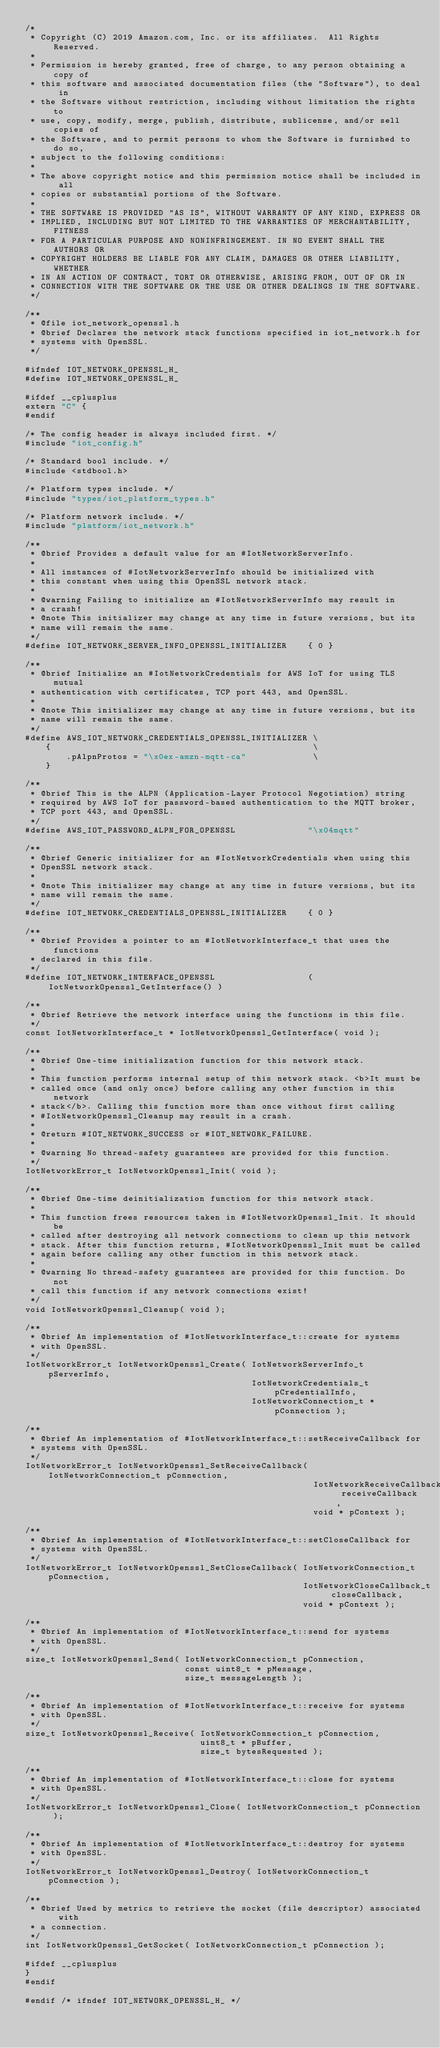<code> <loc_0><loc_0><loc_500><loc_500><_C_>/*
 * Copyright (C) 2019 Amazon.com, Inc. or its affiliates.  All Rights Reserved.
 *
 * Permission is hereby granted, free of charge, to any person obtaining a copy of
 * this software and associated documentation files (the "Software"), to deal in
 * the Software without restriction, including without limitation the rights to
 * use, copy, modify, merge, publish, distribute, sublicense, and/or sell copies of
 * the Software, and to permit persons to whom the Software is furnished to do so,
 * subject to the following conditions:
 *
 * The above copyright notice and this permission notice shall be included in all
 * copies or substantial portions of the Software.
 *
 * THE SOFTWARE IS PROVIDED "AS IS", WITHOUT WARRANTY OF ANY KIND, EXPRESS OR
 * IMPLIED, INCLUDING BUT NOT LIMITED TO THE WARRANTIES OF MERCHANTABILITY, FITNESS
 * FOR A PARTICULAR PURPOSE AND NONINFRINGEMENT. IN NO EVENT SHALL THE AUTHORS OR
 * COPYRIGHT HOLDERS BE LIABLE FOR ANY CLAIM, DAMAGES OR OTHER LIABILITY, WHETHER
 * IN AN ACTION OF CONTRACT, TORT OR OTHERWISE, ARISING FROM, OUT OF OR IN
 * CONNECTION WITH THE SOFTWARE OR THE USE OR OTHER DEALINGS IN THE SOFTWARE.
 */

/**
 * @file iot_network_openssl.h
 * @brief Declares the network stack functions specified in iot_network.h for
 * systems with OpenSSL.
 */

#ifndef IOT_NETWORK_OPENSSL_H_
#define IOT_NETWORK_OPENSSL_H_

#ifdef __cplusplus
extern "C" {
#endif

/* The config header is always included first. */
#include "iot_config.h"

/* Standard bool include. */
#include <stdbool.h>

/* Platform types include. */
#include "types/iot_platform_types.h"

/* Platform network include. */
#include "platform/iot_network.h"

/**
 * @brief Provides a default value for an #IotNetworkServerInfo.
 *
 * All instances of #IotNetworkServerInfo should be initialized with
 * this constant when using this OpenSSL network stack.
 *
 * @warning Failing to initialize an #IotNetworkServerInfo may result in
 * a crash!
 * @note This initializer may change at any time in future versions, but its
 * name will remain the same.
 */
#define IOT_NETWORK_SERVER_INFO_OPENSSL_INITIALIZER    { 0 }

/**
 * @brief Initialize an #IotNetworkCredentials for AWS IoT for using TLS mutual
 * authentication with certificates, TCP port 443, and OpenSSL.
 *
 * @note This initializer may change at any time in future versions, but its
 * name will remain the same.
 */
#define AWS_IOT_NETWORK_CREDENTIALS_OPENSSL_INITIALIZER \
    {                                                   \
        .pAlpnProtos = "\x0ex-amzn-mqtt-ca"             \
    }

/**
 * @brief This is the ALPN (Application-Layer Protocol Negotiation) string
 * required by AWS IoT for password-based authentication to the MQTT broker,
 * TCP port 443, and OpenSSL.
 */
#define AWS_IOT_PASSWORD_ALPN_FOR_OPENSSL              "\x04mqtt"

/**
 * @brief Generic initializer for an #IotNetworkCredentials when using this
 * OpenSSL network stack.
 *
 * @note This initializer may change at any time in future versions, but its
 * name will remain the same.
 */
#define IOT_NETWORK_CREDENTIALS_OPENSSL_INITIALIZER    { 0 }

/**
 * @brief Provides a pointer to an #IotNetworkInterface_t that uses the functions
 * declared in this file.
 */
#define IOT_NETWORK_INTERFACE_OPENSSL                  ( IotNetworkOpenssl_GetInterface() )

/**
 * @brief Retrieve the network interface using the functions in this file.
 */
const IotNetworkInterface_t * IotNetworkOpenssl_GetInterface( void );

/**
 * @brief One-time initialization function for this network stack.
 *
 * This function performs internal setup of this network stack. <b>It must be
 * called once (and only once) before calling any other function in this network
 * stack</b>. Calling this function more than once without first calling
 * #IotNetworkOpenssl_Cleanup may result in a crash.
 *
 * @return #IOT_NETWORK_SUCCESS or #IOT_NETWORK_FAILURE.
 *
 * @warning No thread-safety guarantees are provided for this function.
 */
IotNetworkError_t IotNetworkOpenssl_Init( void );

/**
 * @brief One-time deinitialization function for this network stack.
 *
 * This function frees resources taken in #IotNetworkOpenssl_Init. It should be
 * called after destroying all network connections to clean up this network
 * stack. After this function returns, #IotNetworkOpenssl_Init must be called
 * again before calling any other function in this network stack.
 *
 * @warning No thread-safety guarantees are provided for this function. Do not
 * call this function if any network connections exist!
 */
void IotNetworkOpenssl_Cleanup( void );

/**
 * @brief An implementation of #IotNetworkInterface_t::create for systems
 * with OpenSSL.
 */
IotNetworkError_t IotNetworkOpenssl_Create( IotNetworkServerInfo_t pServerInfo,
                                            IotNetworkCredentials_t pCredentialInfo,
                                            IotNetworkConnection_t * pConnection );

/**
 * @brief An implementation of #IotNetworkInterface_t::setReceiveCallback for
 * systems with OpenSSL.
 */
IotNetworkError_t IotNetworkOpenssl_SetReceiveCallback( IotNetworkConnection_t pConnection,
                                                        IotNetworkReceiveCallback_t receiveCallback,
                                                        void * pContext );

/**
 * @brief An implementation of #IotNetworkInterface_t::setCloseCallback for
 * systems with OpenSSL.
 */
IotNetworkError_t IotNetworkOpenssl_SetCloseCallback( IotNetworkConnection_t pConnection,
                                                      IotNetworkCloseCallback_t closeCallback,
                                                      void * pContext );

/**
 * @brief An implementation of #IotNetworkInterface_t::send for systems
 * with OpenSSL.
 */
size_t IotNetworkOpenssl_Send( IotNetworkConnection_t pConnection,
                               const uint8_t * pMessage,
                               size_t messageLength );

/**
 * @brief An implementation of #IotNetworkInterface_t::receive for systems
 * with OpenSSL.
 */
size_t IotNetworkOpenssl_Receive( IotNetworkConnection_t pConnection,
                                  uint8_t * pBuffer,
                                  size_t bytesRequested );

/**
 * @brief An implementation of #IotNetworkInterface_t::close for systems
 * with OpenSSL.
 */
IotNetworkError_t IotNetworkOpenssl_Close( IotNetworkConnection_t pConnection );

/**
 * @brief An implementation of #IotNetworkInterface_t::destroy for systems
 * with OpenSSL.
 */
IotNetworkError_t IotNetworkOpenssl_Destroy( IotNetworkConnection_t pConnection );

/**
 * @brief Used by metrics to retrieve the socket (file descriptor) associated with
 * a connection.
 */
int IotNetworkOpenssl_GetSocket( IotNetworkConnection_t pConnection );

#ifdef __cplusplus
}
#endif

#endif /* ifndef IOT_NETWORK_OPENSSL_H_ */
</code> 